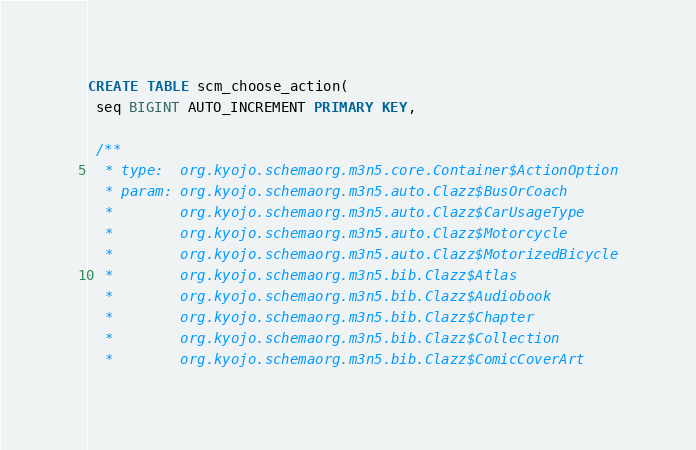<code> <loc_0><loc_0><loc_500><loc_500><_SQL_>CREATE TABLE scm_choose_action(
 seq BIGINT AUTO_INCREMENT PRIMARY KEY,

 /**
  * type:  org.kyojo.schemaorg.m3n5.core.Container$ActionOption
  * param: org.kyojo.schemaorg.m3n5.auto.Clazz$BusOrCoach
  *        org.kyojo.schemaorg.m3n5.auto.Clazz$CarUsageType
  *        org.kyojo.schemaorg.m3n5.auto.Clazz$Motorcycle
  *        org.kyojo.schemaorg.m3n5.auto.Clazz$MotorizedBicycle
  *        org.kyojo.schemaorg.m3n5.bib.Clazz$Atlas
  *        org.kyojo.schemaorg.m3n5.bib.Clazz$Audiobook
  *        org.kyojo.schemaorg.m3n5.bib.Clazz$Chapter
  *        org.kyojo.schemaorg.m3n5.bib.Clazz$Collection
  *        org.kyojo.schemaorg.m3n5.bib.Clazz$ComicCoverArt</code> 